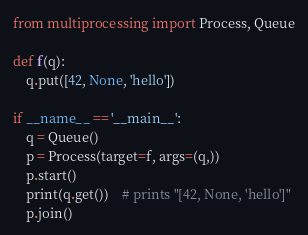Convert code to text. <code><loc_0><loc_0><loc_500><loc_500><_Python_>from multiprocessing import Process, Queue

def f(q):
    q.put([42, None, 'hello'])

if __name__ == '__main__':
    q = Queue()
    p = Process(target=f, args=(q,))
    p.start()
    print(q.get())    # prints "[42, None, 'hello']"
    p.join()
</code> 